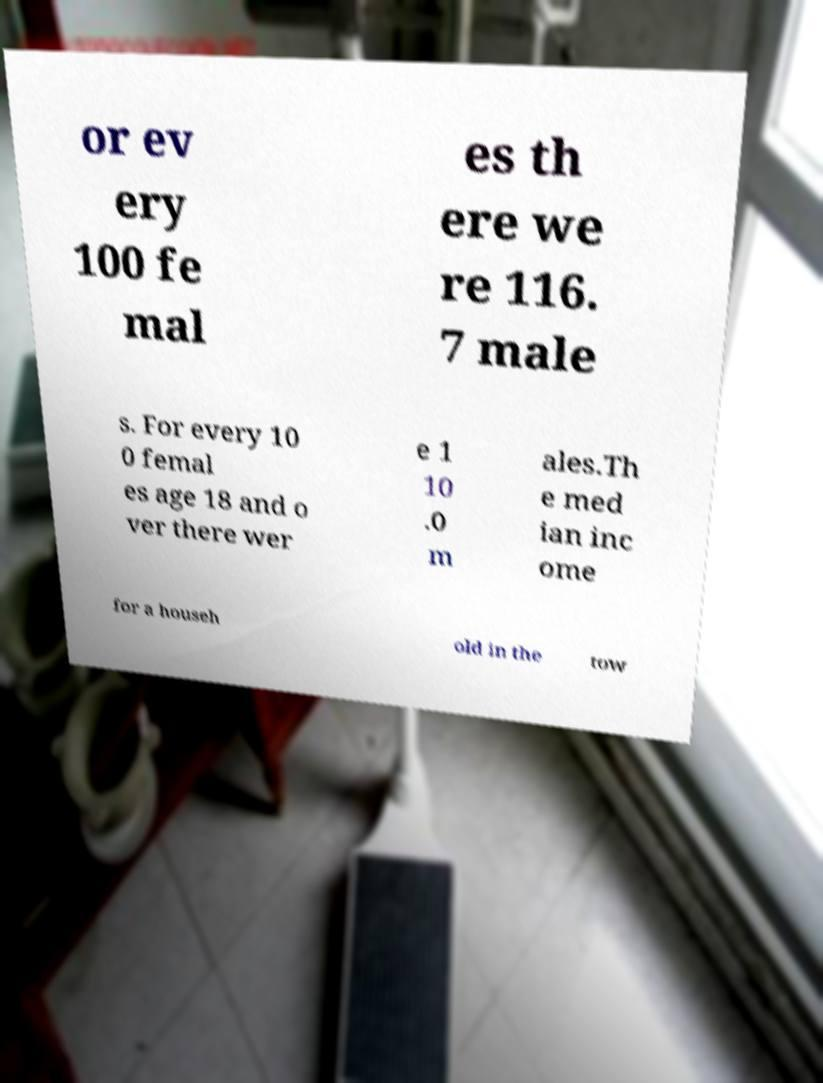Could you assist in decoding the text presented in this image and type it out clearly? or ev ery 100 fe mal es th ere we re 116. 7 male s. For every 10 0 femal es age 18 and o ver there wer e 1 10 .0 m ales.Th e med ian inc ome for a househ old in the tow 